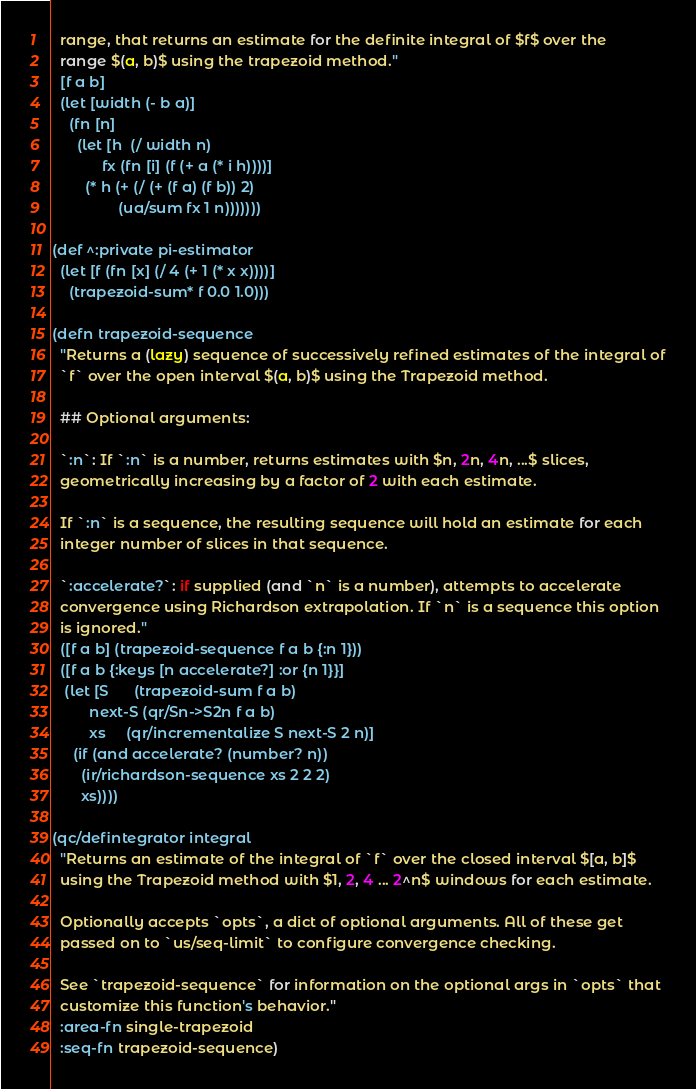<code> <loc_0><loc_0><loc_500><loc_500><_Clojure_>  range, that returns an estimate for the definite integral of $f$ over the
  range $(a, b)$ using the trapezoid method."
  [f a b]
  (let [width (- b a)]
    (fn [n]
      (let [h  (/ width n)
            fx (fn [i] (f (+ a (* i h))))]
        (* h (+ (/ (+ (f a) (f b)) 2)
                (ua/sum fx 1 n)))))))

(def ^:private pi-estimator
  (let [f (fn [x] (/ 4 (+ 1 (* x x))))]
    (trapezoid-sum* f 0.0 1.0)))

(defn trapezoid-sequence
  "Returns a (lazy) sequence of successively refined estimates of the integral of
  `f` over the open interval $(a, b)$ using the Trapezoid method.

  ## Optional arguments:

  `:n`: If `:n` is a number, returns estimates with $n, 2n, 4n, ...$ slices,
  geometrically increasing by a factor of 2 with each estimate.

  If `:n` is a sequence, the resulting sequence will hold an estimate for each
  integer number of slices in that sequence.

  `:accelerate?`: if supplied (and `n` is a number), attempts to accelerate
  convergence using Richardson extrapolation. If `n` is a sequence this option
  is ignored."
  ([f a b] (trapezoid-sequence f a b {:n 1}))
  ([f a b {:keys [n accelerate?] :or {n 1}}]
   (let [S      (trapezoid-sum f a b)
         next-S (qr/Sn->S2n f a b)
         xs     (qr/incrementalize S next-S 2 n)]
     (if (and accelerate? (number? n))
       (ir/richardson-sequence xs 2 2 2)
       xs))))

(qc/defintegrator integral
  "Returns an estimate of the integral of `f` over the closed interval $[a, b]$
  using the Trapezoid method with $1, 2, 4 ... 2^n$ windows for each estimate.

  Optionally accepts `opts`, a dict of optional arguments. All of these get
  passed on to `us/seq-limit` to configure convergence checking.

  See `trapezoid-sequence` for information on the optional args in `opts` that
  customize this function's behavior."
  :area-fn single-trapezoid
  :seq-fn trapezoid-sequence)
</code> 